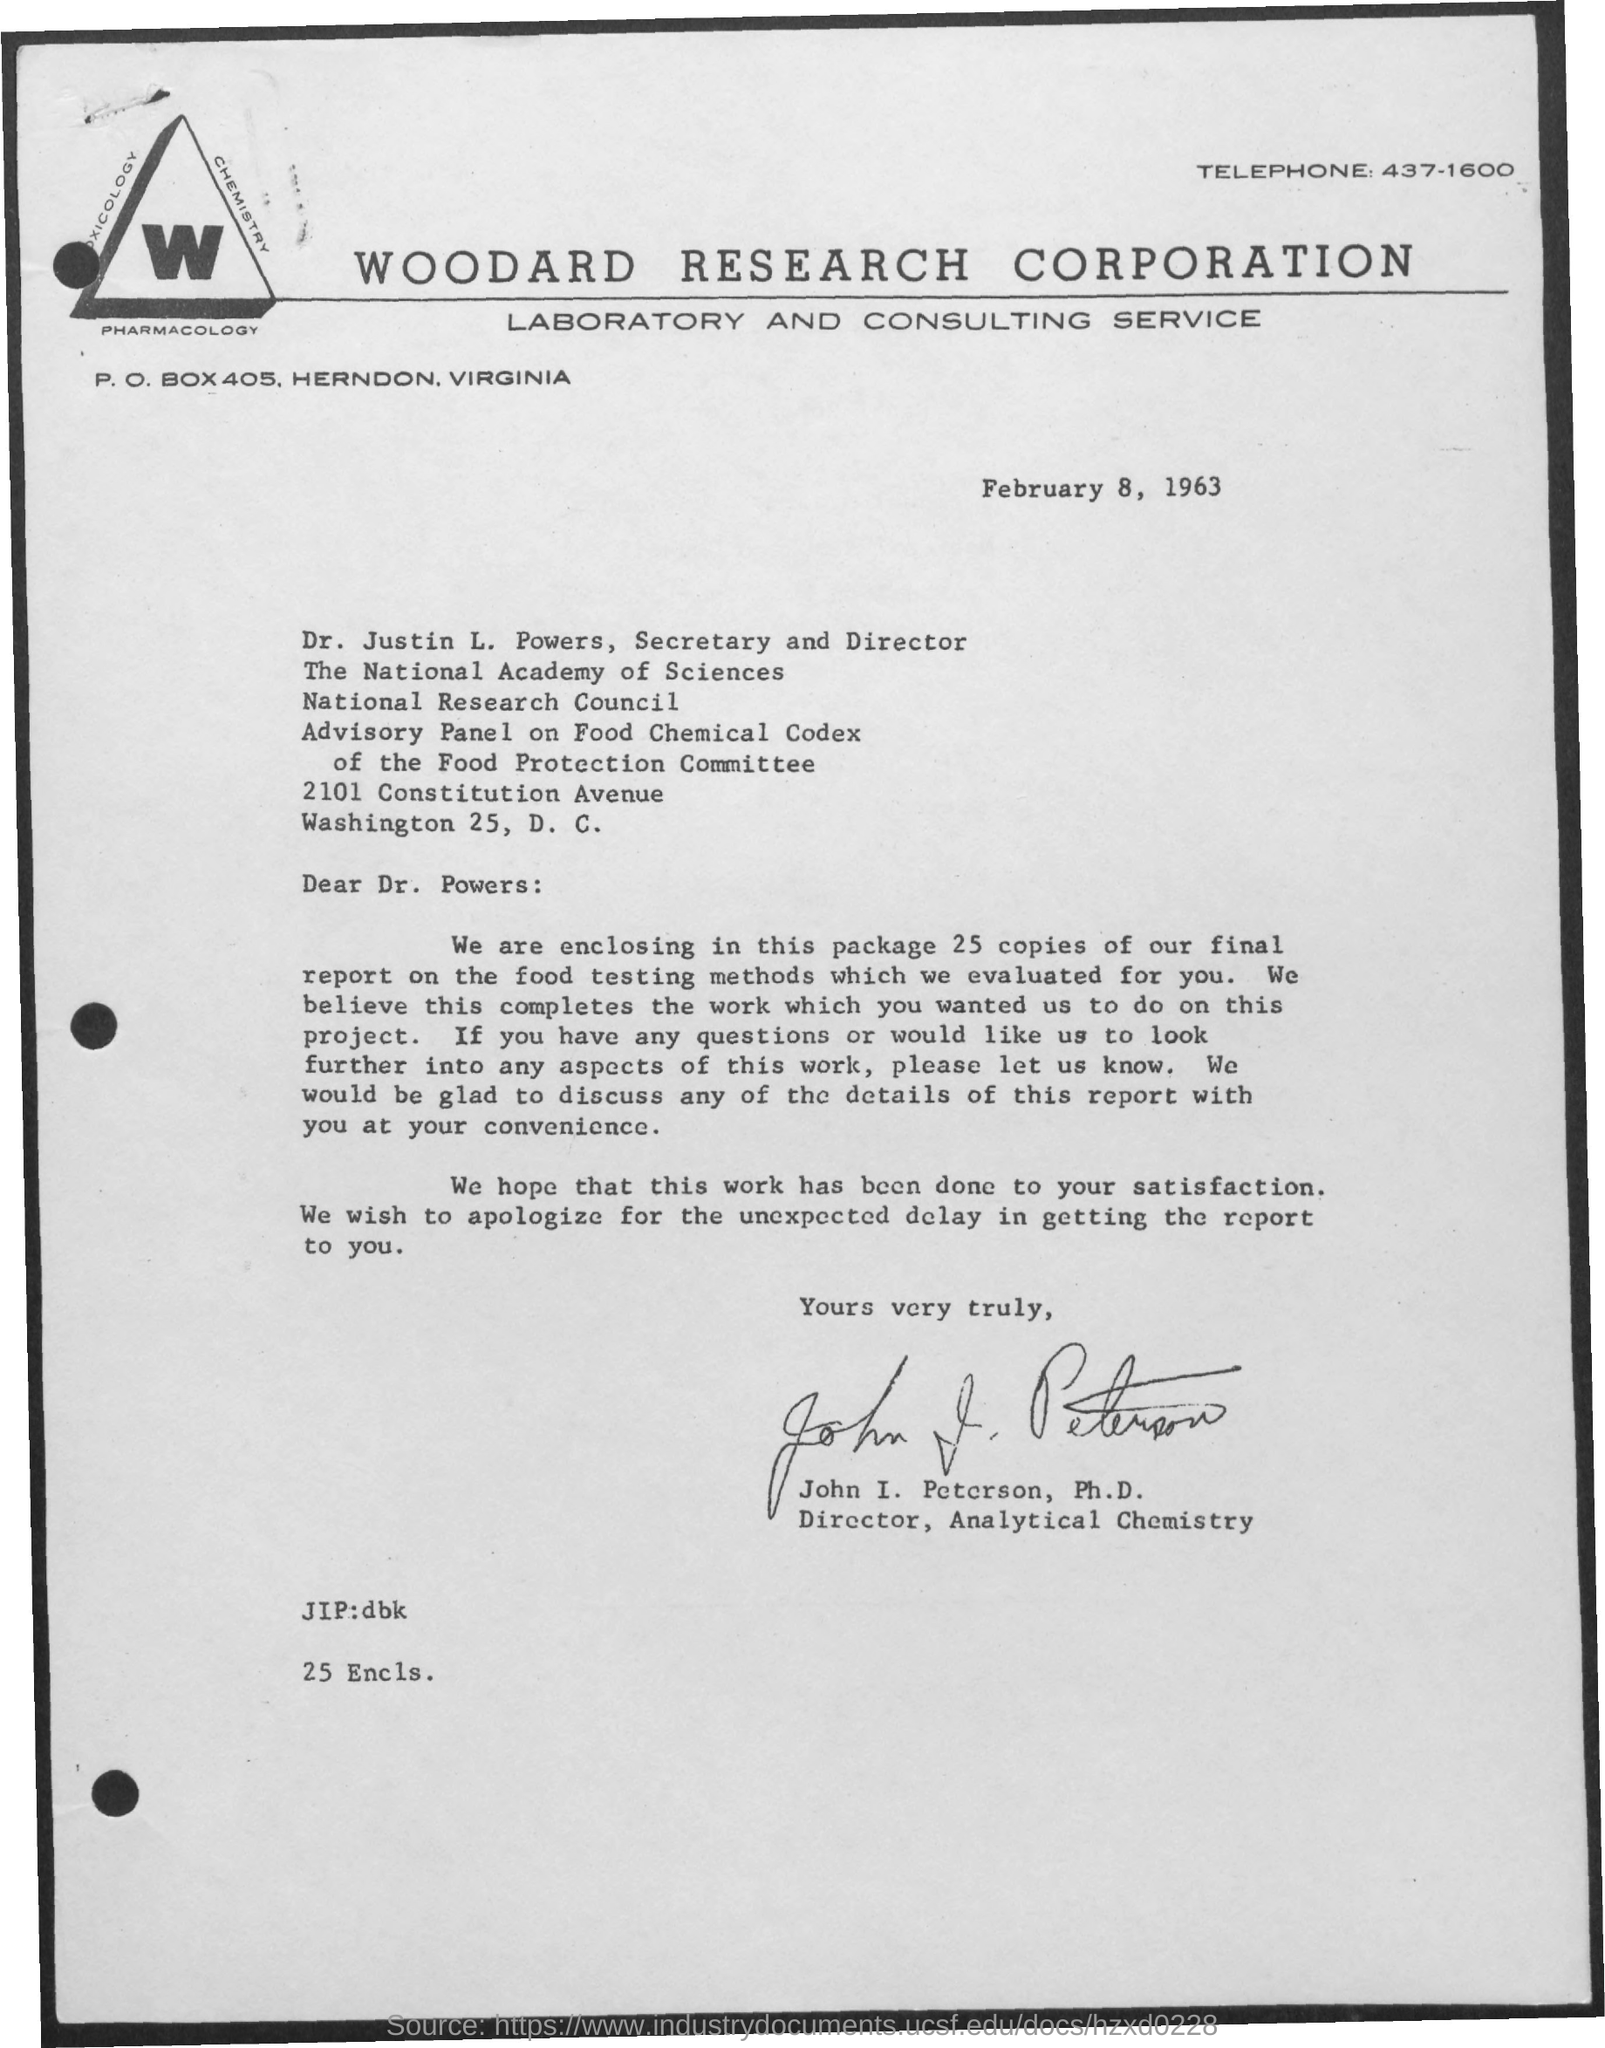Point out several critical features in this image. The telephone number of Woodard Research Corporation Laboratory and Consulting Service is 437-1600. The letter was written by John I. Peterson, Ph.D. There are 25 copies of the final report enclosed with this letter. The P.O. Box number of Woodard Research Corporation Laboratory and Consulting Service is 405... The National Academy of Sciences is headed by Dr. Justin L. Powers, who serves as both the Secretary and Director of the organization. 